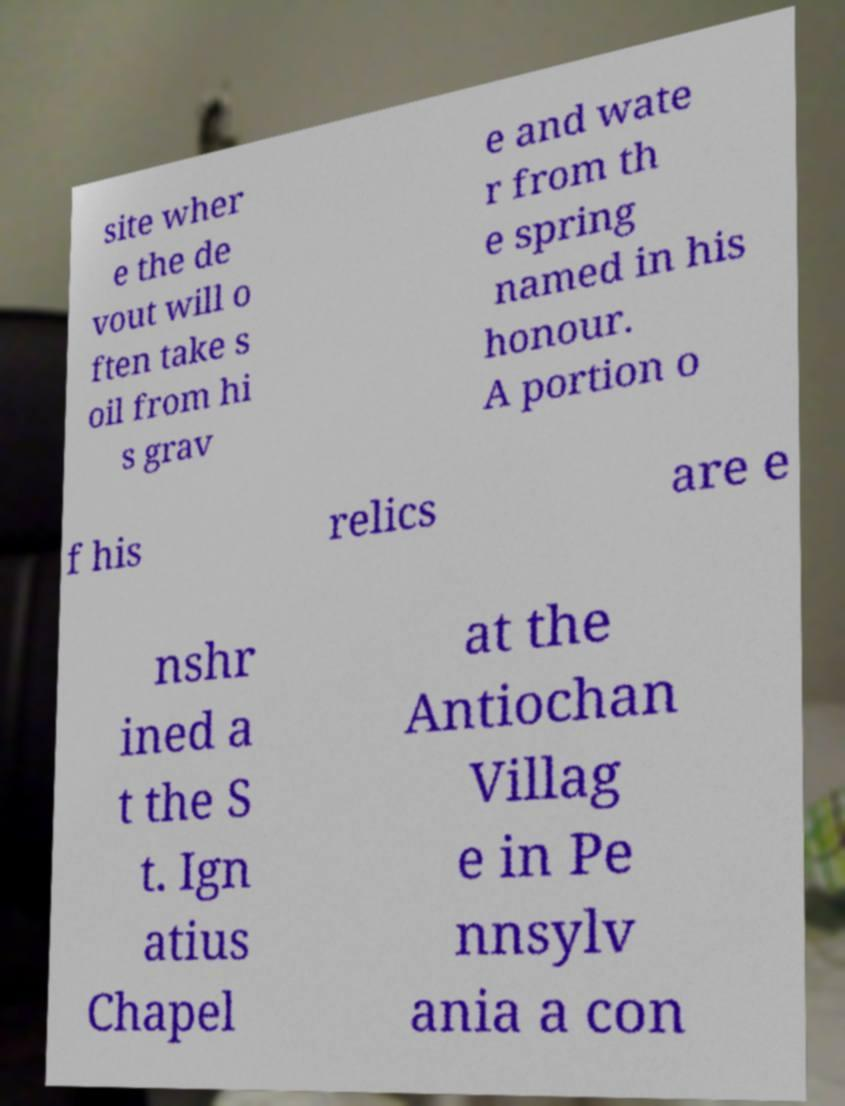What messages or text are displayed in this image? I need them in a readable, typed format. site wher e the de vout will o ften take s oil from hi s grav e and wate r from th e spring named in his honour. A portion o f his relics are e nshr ined a t the S t. Ign atius Chapel at the Antiochan Villag e in Pe nnsylv ania a con 